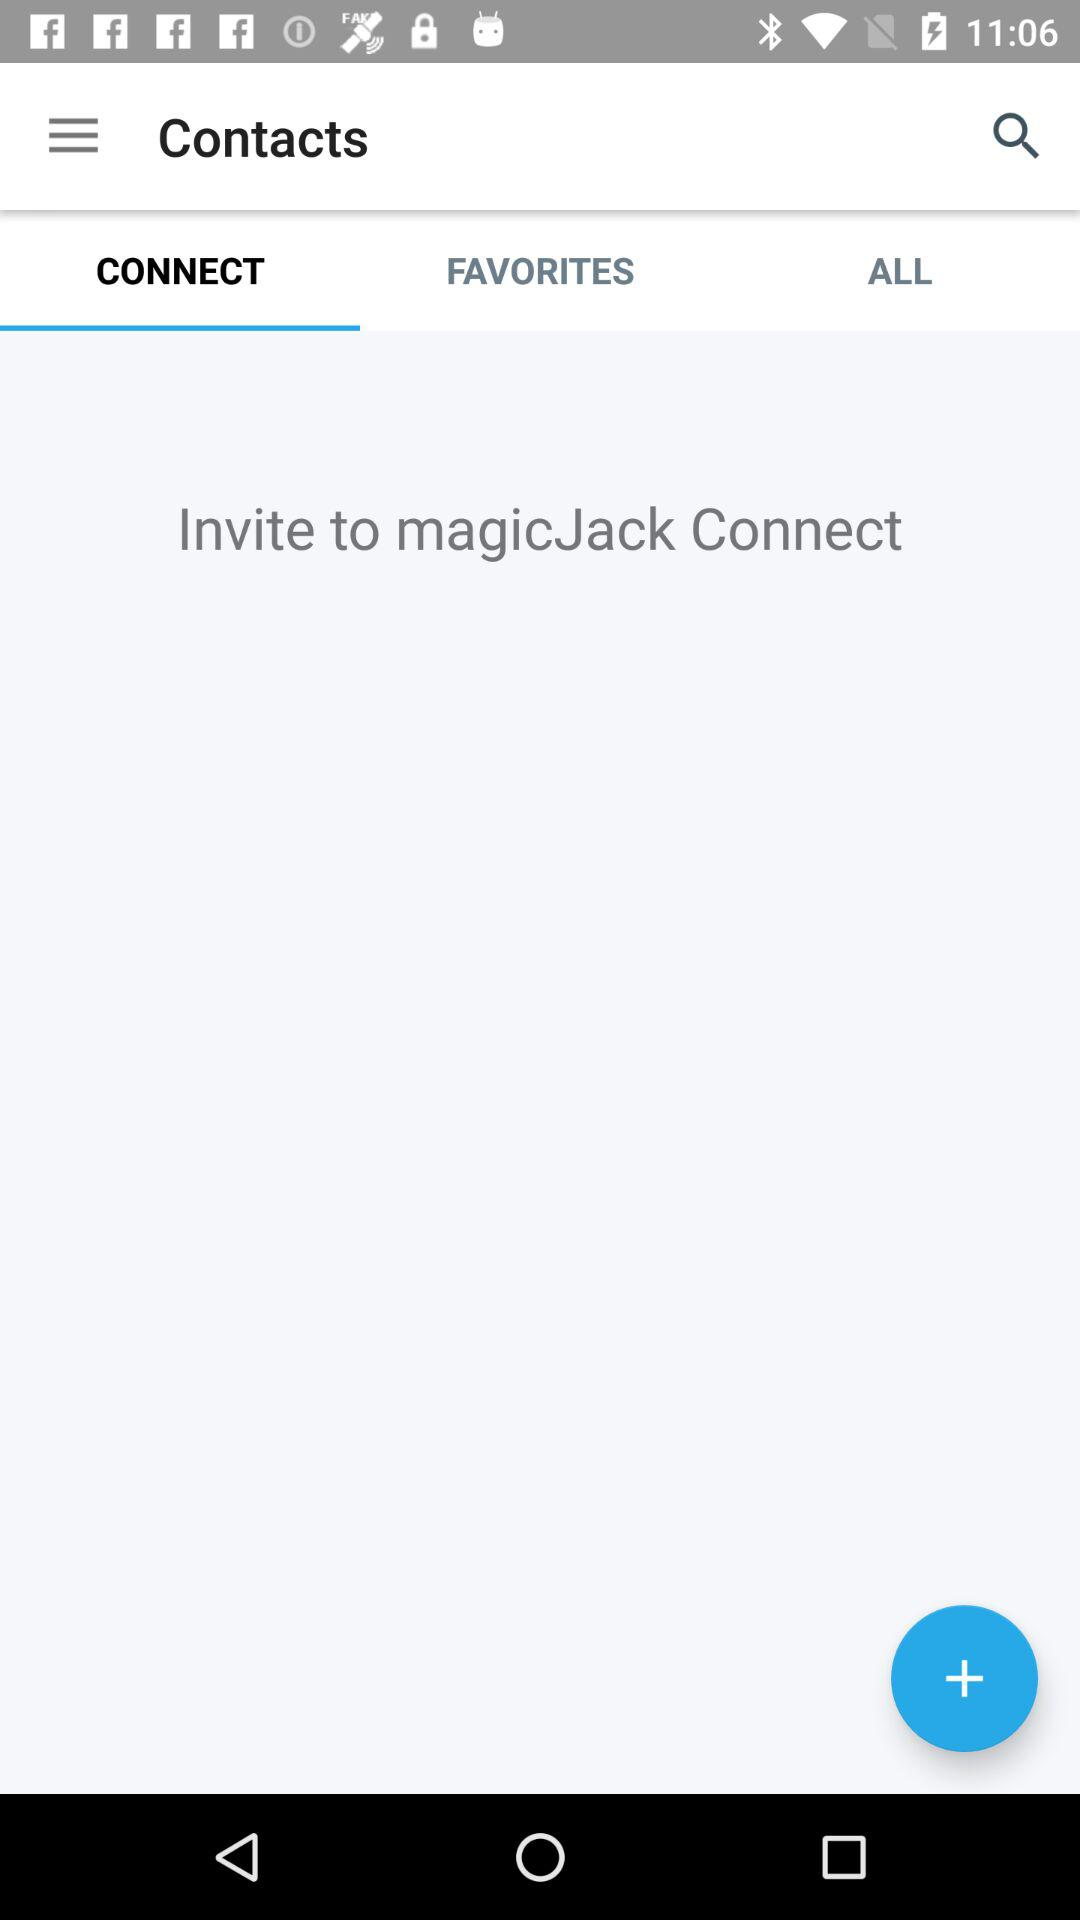Which tab is selected? The selected tab is "CONNECT". 